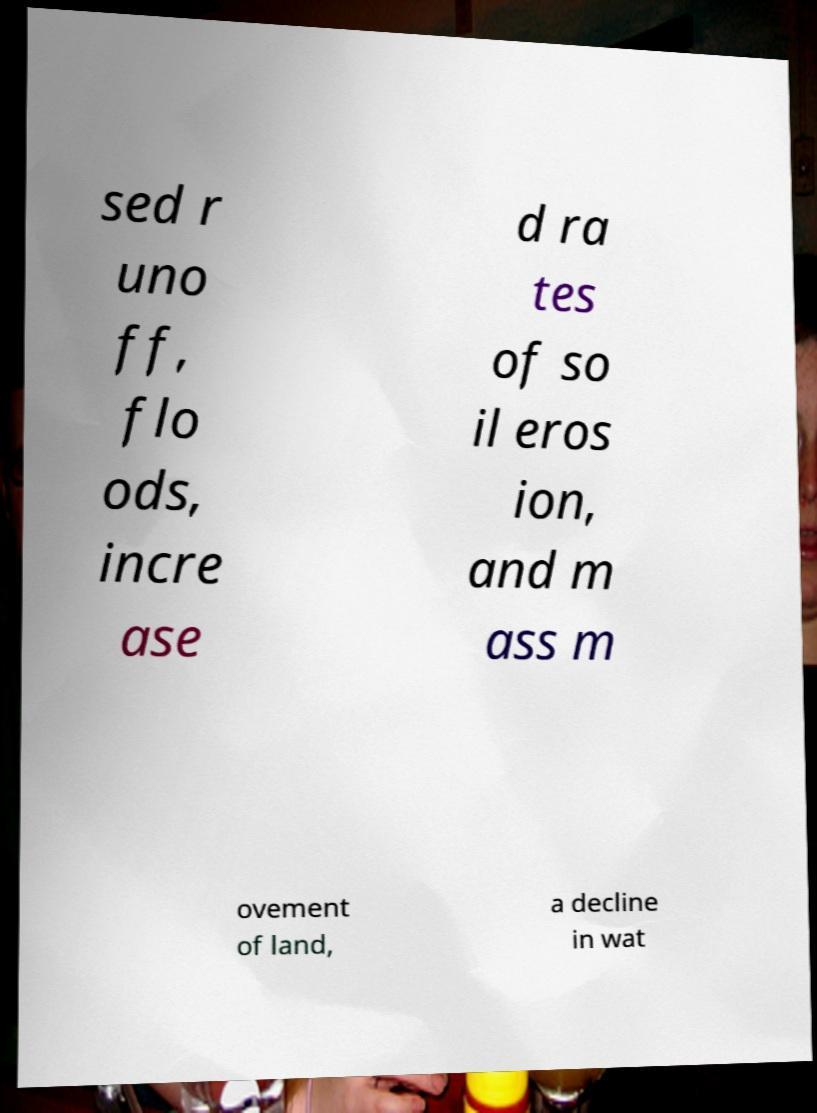Can you read and provide the text displayed in the image?This photo seems to have some interesting text. Can you extract and type it out for me? sed r uno ff, flo ods, incre ase d ra tes of so il eros ion, and m ass m ovement of land, a decline in wat 